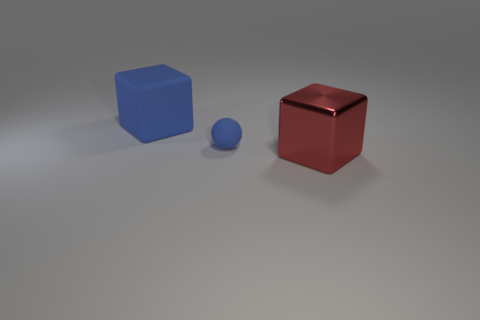Add 1 tiny red rubber spheres. How many objects exist? 4 Subtract all balls. How many objects are left? 2 Add 2 small gray shiny cubes. How many small gray shiny cubes exist? 2 Subtract 0 yellow blocks. How many objects are left? 3 Subtract all big blue matte balls. Subtract all big red metal blocks. How many objects are left? 2 Add 3 red things. How many red things are left? 4 